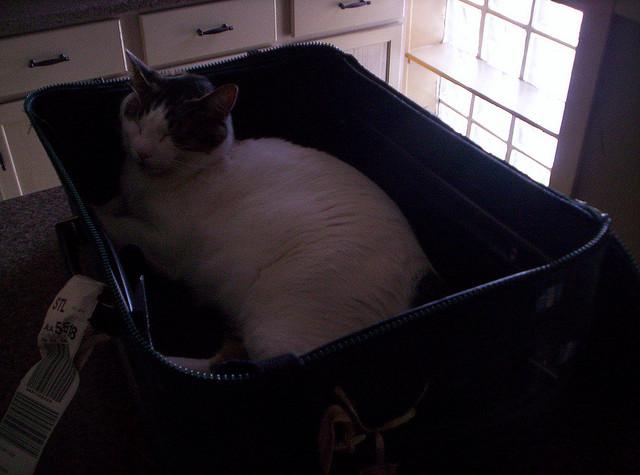What is in the picture?
Write a very short answer. Cat. What is the cat sitting under?
Keep it brief. Suitcase. Does this animal like to lay in boxes?
Be succinct. Yes. Is the cat gray?
Keep it brief. No. Is the cat sleeping?
Keep it brief. Yes. Is the cat awake?
Give a very brief answer. Yes. 